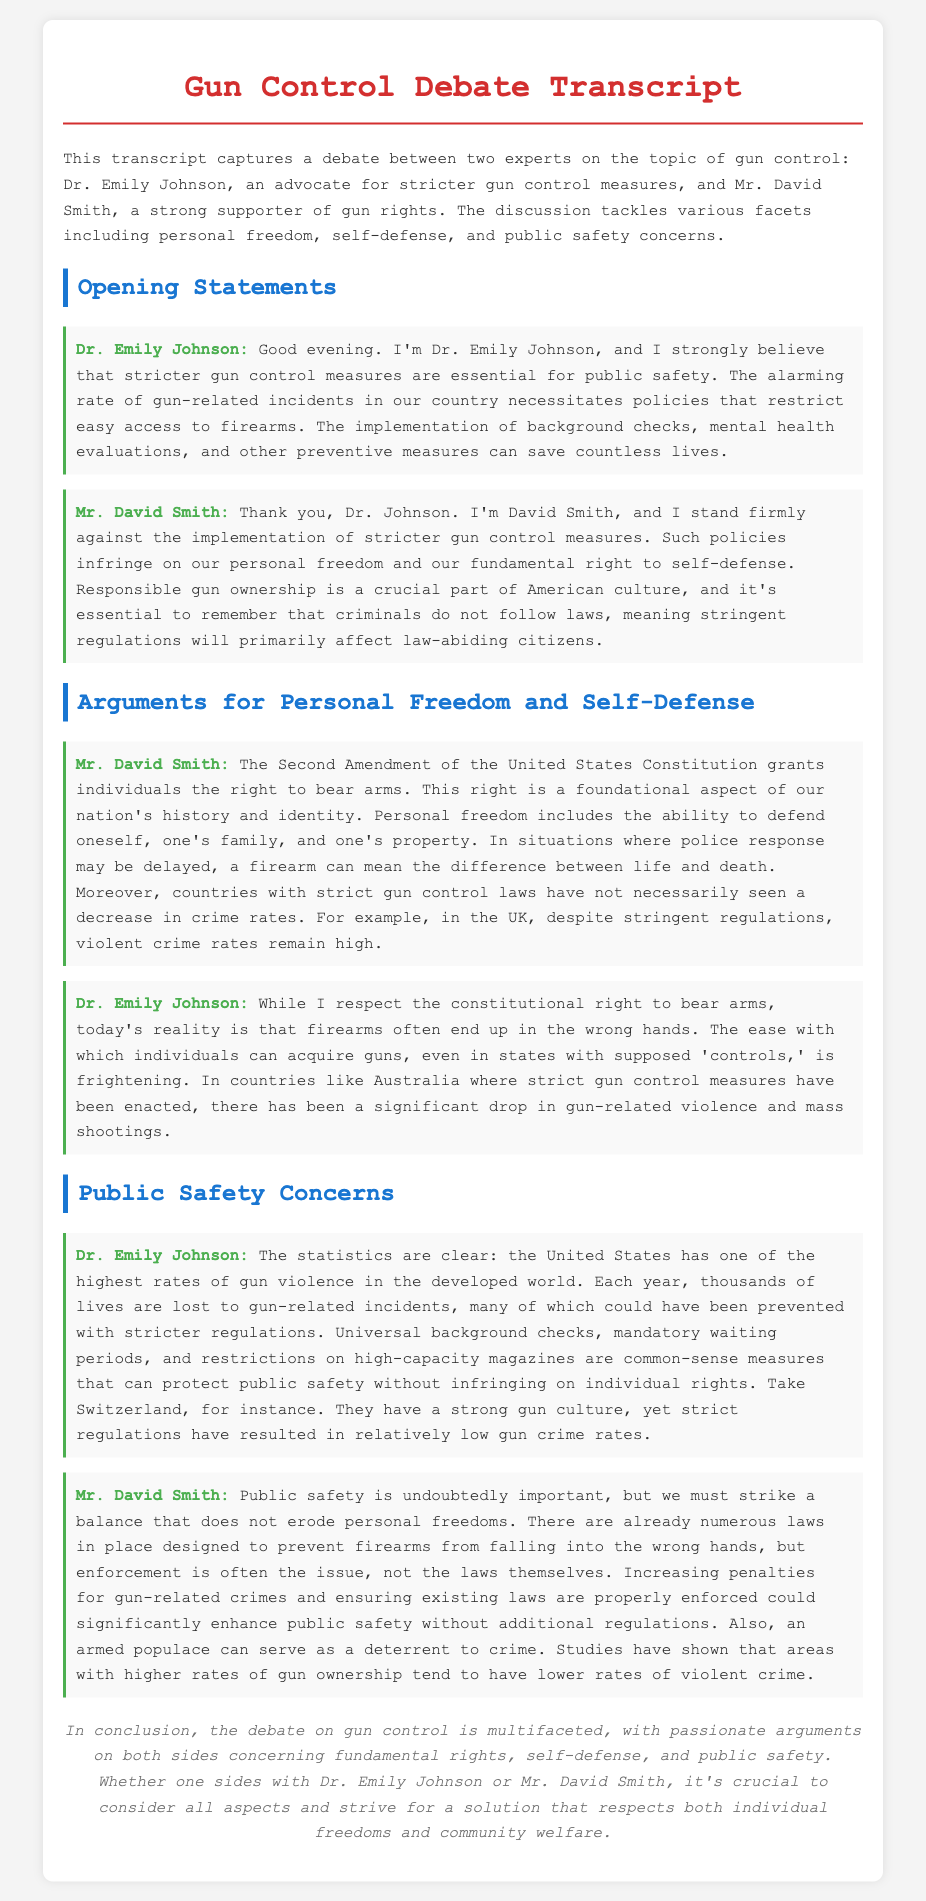What is Dr. Emily Johnson's stance on gun control? Dr. Emily Johnson advocates for stricter gun control measures for public safety.
Answer: Stricter gun control measures What is Mr. David Smith's main argument against gun control? Mr. David Smith argues that gun control measures infringe on personal freedom and self-defense.
Answer: Infringe on personal freedom and self-defense Which amendment is referenced as supporting gun rights? The Second Amendment is referenced as granting individuals the right to bear arms.
Answer: Second Amendment What example does Dr. Emily Johnson use to illustrate successful gun control? Dr. Emily Johnson uses Australia as an example where strict gun control has led to reduced gun-related violence.
Answer: Australia What does Mr. David Smith suggest could enhance public safety? Mr. David Smith suggests that increasing penalties for gun-related crimes and enforcing existing laws could enhance public safety.
Answer: Increasing penalties and enforcing existing laws According to the transcript, what has been the trend in gun-related incidents in the U.S.? The transcript states that the U.S. has one of the highest rates of gun violence in the developed world.
Answer: Highest rates of gun violence What does Dr. Emily Johnson propose as common-sense measures for gun control? Dr. Emily Johnson proposes universal background checks, mandatory waiting periods, and restrictions on high-capacity magazines as common-sense measures.
Answer: Universal background checks and mandatory waiting periods How does Mr. David Smith argue that an armed populace affects crime rates? Mr. David Smith argues that an armed populace can serve as a deterrent to crime and that areas with higher rates of gun ownership tend to have lower rates of violent crime.
Answer: Deterrent to crime What is the concluding sentiment about the debate on gun control? The conclusion emphasizes the multifaceted nature of the debate and the importance of considering individual freedoms and community welfare.
Answer: Multifaceted and considers individual freedoms and community welfare 